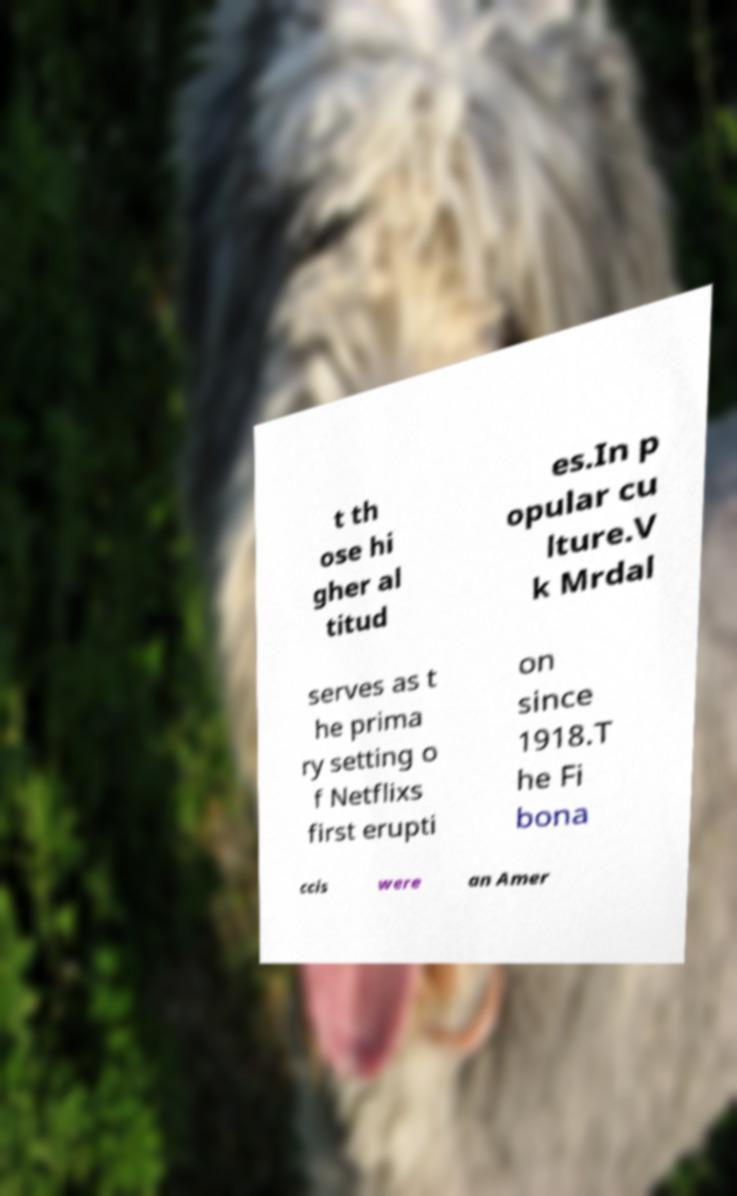There's text embedded in this image that I need extracted. Can you transcribe it verbatim? t th ose hi gher al titud es.In p opular cu lture.V k Mrdal serves as t he prima ry setting o f Netflixs first erupti on since 1918.T he Fi bona ccis were an Amer 